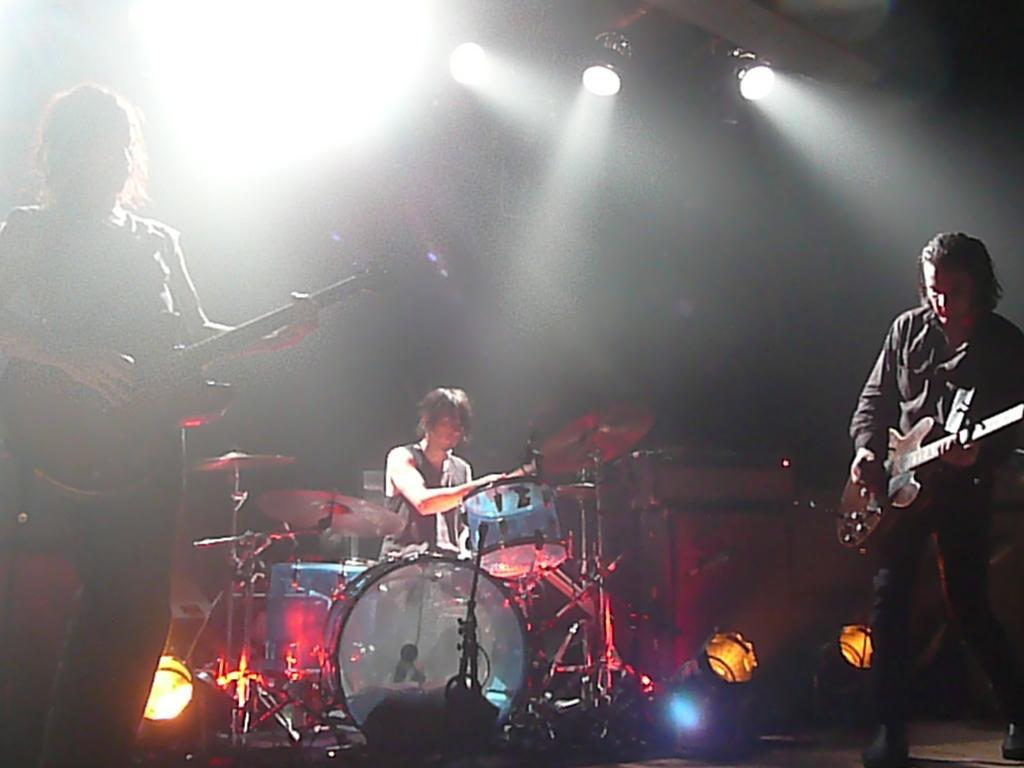How would you summarize this image in a sentence or two? In this picture there is a man and a woman playing a guitar. There is a person sitting on the chair. There is a drum and other musical instruments. There are some lights at the background. 